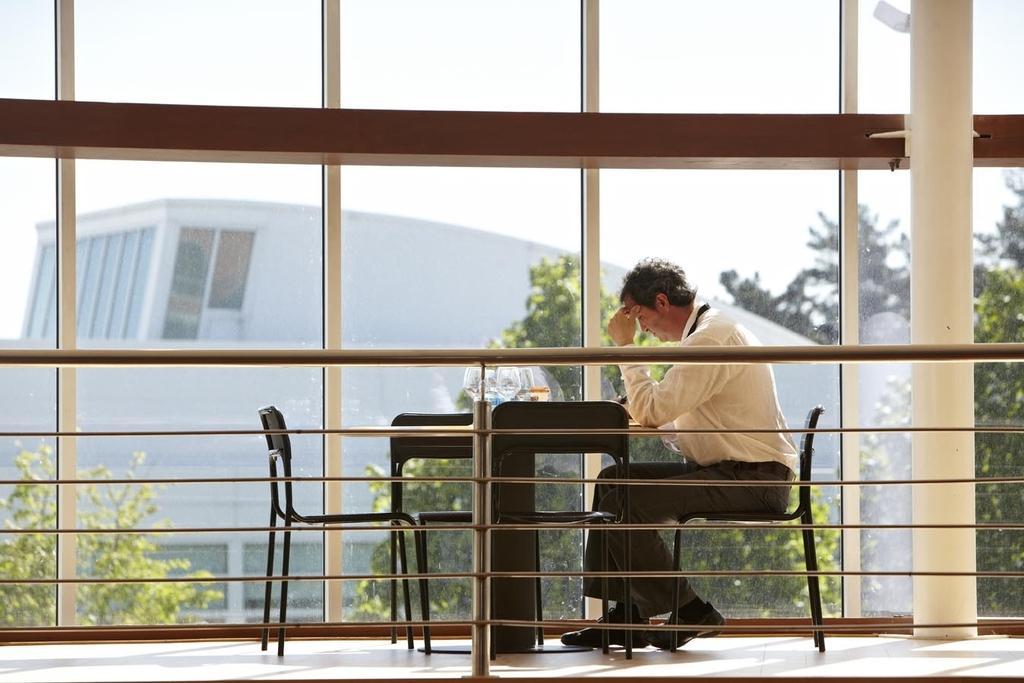In one or two sentences, can you explain what this image depicts? In this image, we can see a table and some chairs. This table contains glasses. There is a person in the middle of the image sitting on the chair beside the glass wall. There are grills at the bottom of the image. There is a pillar on the right side of the image. In the background, we can see some trees, building and sky. 